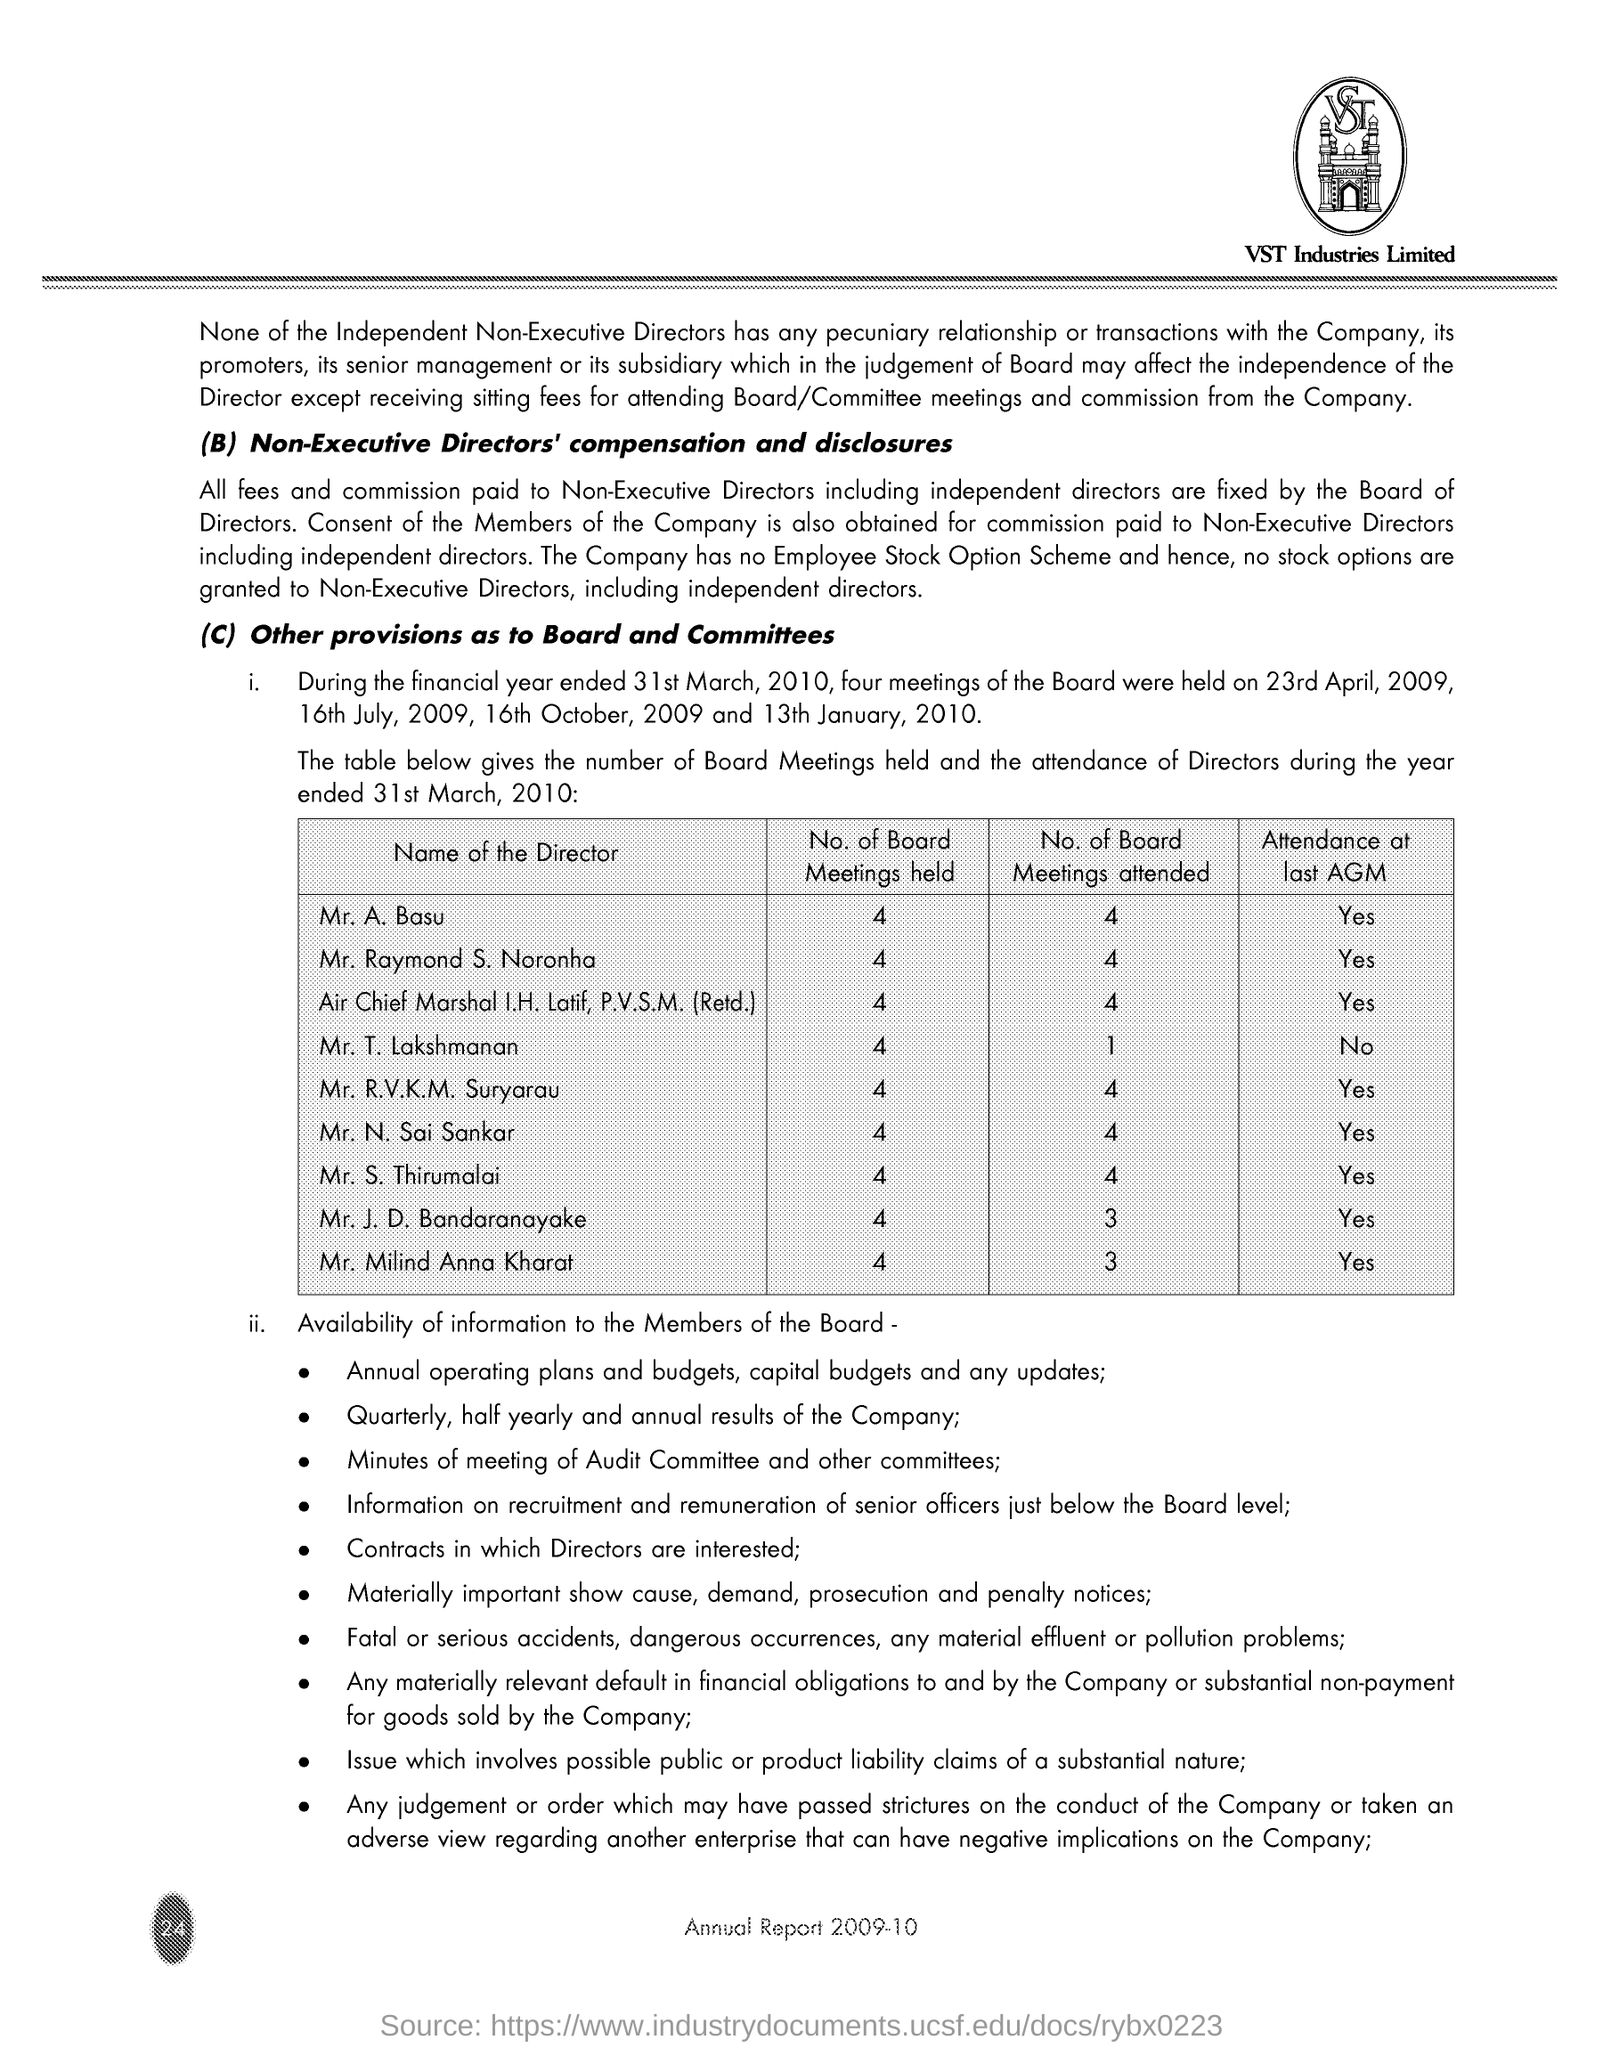Draw attention to some important aspects in this diagram. The company name is VST Industries Limited. 